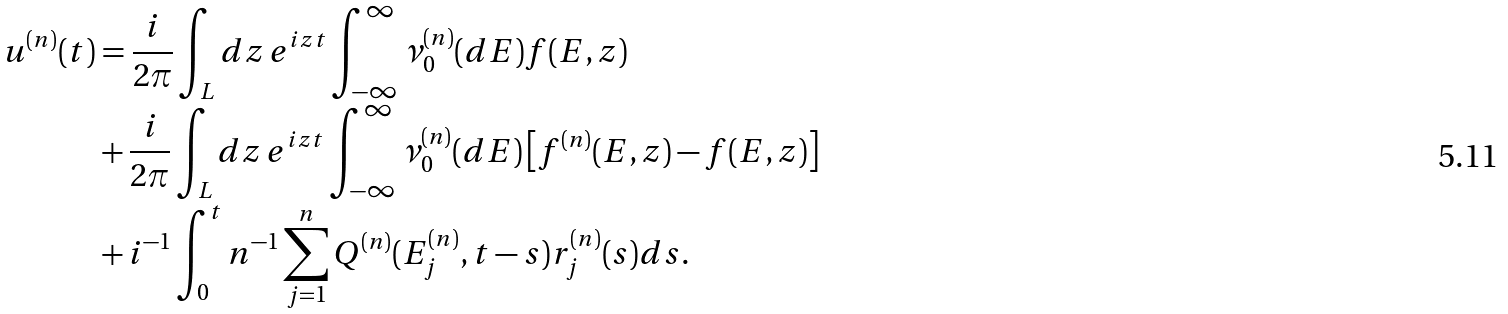<formula> <loc_0><loc_0><loc_500><loc_500>u ^ { ( n ) } ( t ) & = \frac { i } { 2 \pi } \int _ { L } d z \, e ^ { i z t } \int _ { - \infty } ^ { \infty } \nu ^ { ( n ) } _ { 0 } ( d E ) f ( E , z ) \\ & + \frac { i } { 2 \pi } \int _ { L } d z \, e ^ { i z t } \int _ { - \infty } ^ { \infty } \nu _ { 0 } ^ { ( n ) } ( d E ) \left [ f ^ { ( n ) } ( E , z ) - f ( E , z ) \right ] \\ & + i ^ { - 1 } \int _ { 0 } ^ { t } n ^ { - 1 } \sum _ { j = 1 } ^ { n } Q ^ { ( n ) } ( E _ { j } ^ { ( n ) } , t - s ) r _ { j } ^ { ( n ) } ( s ) d s .</formula> 